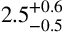Convert formula to latex. <formula><loc_0><loc_0><loc_500><loc_500>2 . 5 _ { - 0 . 5 } ^ { + 0 . 6 }</formula> 